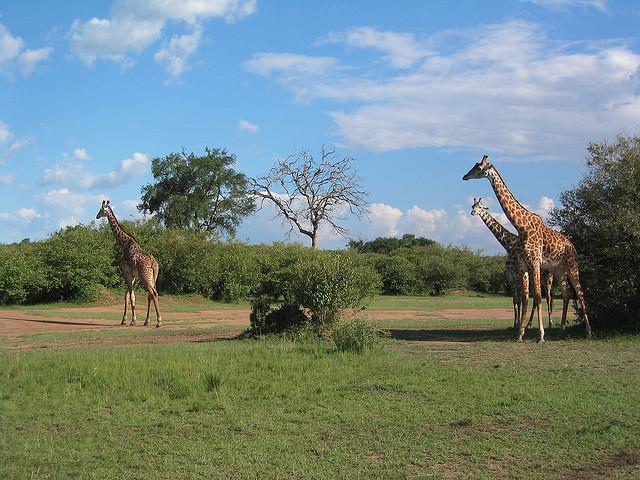How many animals are in the picture?
Be succinct. 3. Where are the giraffe's heading too?
Give a very brief answer. Left. Do the giraffes have wet feet?
Keep it brief. No. What kind of landscape is this?
Short answer required. Field. How many giraffes are in this picture?
Answer briefly. 3. Can you see trees in the picture?
Concise answer only. Yes. What is this animal doing?
Answer briefly. Standing. Is this a small suburban park?
Be succinct. No. Can this animal have two heads?
Quick response, please. No. How many giraffes are seen?
Keep it brief. 3. Is there a statue?
Be succinct. No. Is the single giraffe walking away from the others?
Short answer required. Yes. Are the giraffes at the zoo?
Keep it brief. No. 